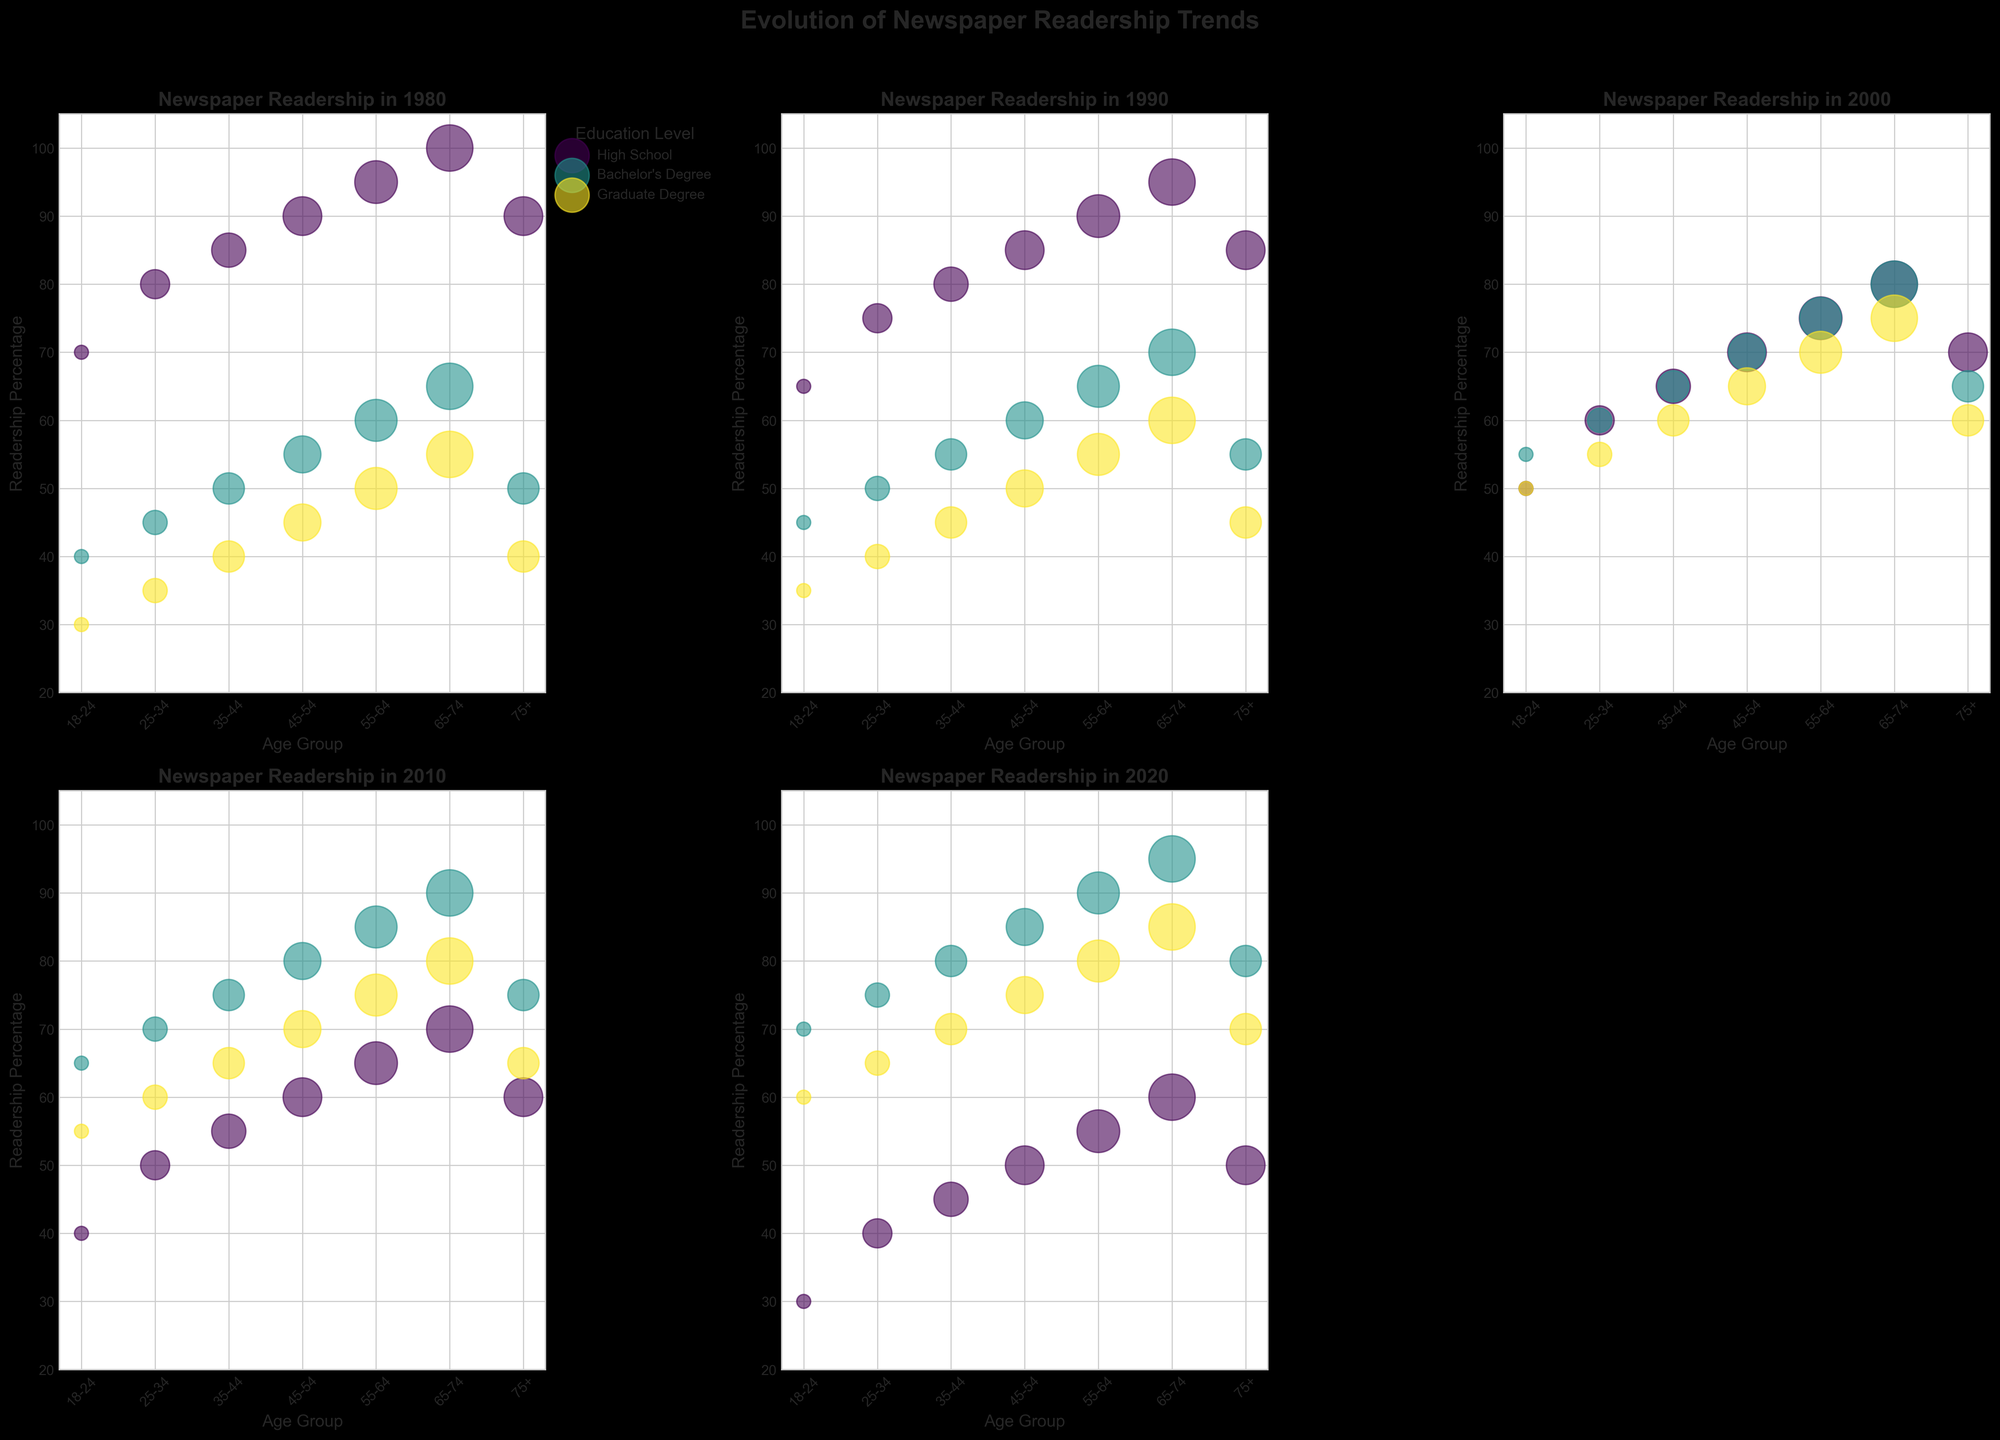What is the title of the entire subplot? The title of the subplot is displayed prominently at the top and is meant to provide an overall understanding of the figure's subject matter. In this case, the title is located above all subplots and reads "Evolution of Newspaper Readership Trends".
Answer: Evolution of Newspaper Readership Trends Which age group has the highest readership percentage for high school education level in 1980? To answer this, you need to look at the subplot for the year 1980. Identify the bubble with the label 'High School' and examine the 'Age Group' axis to determine which age group has the highest value on the 'Readership Percentage' axis. The largest bubble corresponds to the 65-74 age group.
Answer: 65-74 How did the readership percentage change for those with a Bachelor's degree in the 18-24 age group from 1980 to 2020? Examine the subplots for 1980 and 2020. Locate the bubbles for the 'Bachelor's Degree' within the 18-24 age group and observe their positions on the 'Readership Percentage' axis. In 1980, it is at 40%, and in 2020, it is at 70%, indicating an increase of 30%.
Answer: It increased by 30% Among the age groups, which has the lowest readership percentage for a graduate degree in 2020? Look at the subplot for the year 2020. Find all bubbles labeled 'Graduate Degree', then compare their positions on the 'Readership Percentage' axis across all age groups. The lowest position corresponds to the 75+ age group at 70%.
Answer: 75+ Compare the readership percentage for high school education level between the 35-44 and 65-74 age groups in 2010. Which group had a higher percentage and by how much? In the subplot for 2010, find the bubbles for 'High School' education level within the 35-44 and 65-74 age groups. Compare their heights on the 'Readership Percentage' axis; 35-44 is at 55% and 65-74 is at 70%. The 65-74 age group has a higher percentage by 15%.
Answer: 65-74 had a higher percentage by 15% What educational level shows an increase in newspaper readership percentage in all age groups from 1980 to 2020? Examine the bubbles across all subplots for 1980 and 2020, focusing on each educational level: High School, Bachelor's Degree, and Graduate Degree. Check each age group to see which educational level's readership has increased consistently. Only the Bachelor's Degree level shows an increase in all age groups.
Answer: Bachelor's Degree How does the newspaper readership trend for the 55-64 age group with a Bachelor's degree compare from 1980 to 2020? Examine the plots for the years 1980 and 2020 for the bubbles labeled with 'Bachelor's Degree' in the age group 55-64. The percentage increased from 60% in 1980 to 90% in 2020, showing a significant upward trend.
Answer: It increased by 30% In which year did the gap between the highest and lowest readership percentages for the 45-54 age group with different education levels appear the largest? Compare the bubbles for the 45-54 age group in all the years. Calculate the difference in 'Readership Percentage' between the highest (Bachelor's Degree) and lowest (Graduate Degree or High School) for each year. The largest gap appears in 2020, where the Bachelor's Degree is at 85% and High School is at 50%.
Answer: 2020 